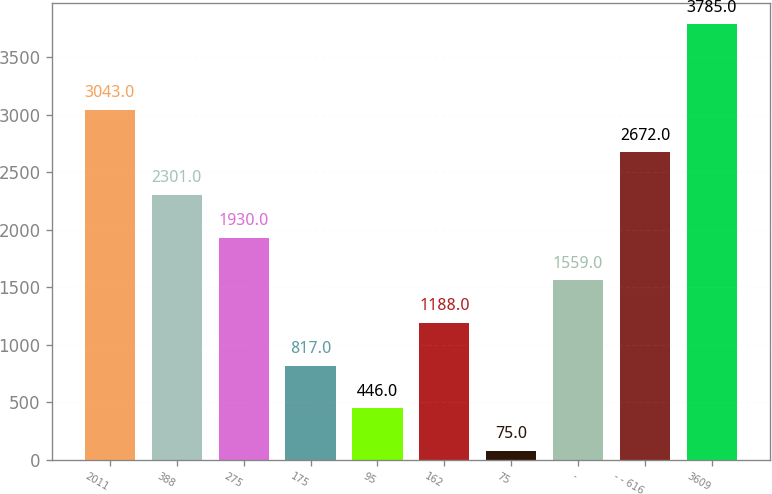Convert chart. <chart><loc_0><loc_0><loc_500><loc_500><bar_chart><fcel>2011<fcel>388<fcel>275<fcel>175<fcel>95<fcel>162<fcel>75<fcel>-<fcel>- - 616<fcel>3609<nl><fcel>3043<fcel>2301<fcel>1930<fcel>817<fcel>446<fcel>1188<fcel>75<fcel>1559<fcel>2672<fcel>3785<nl></chart> 